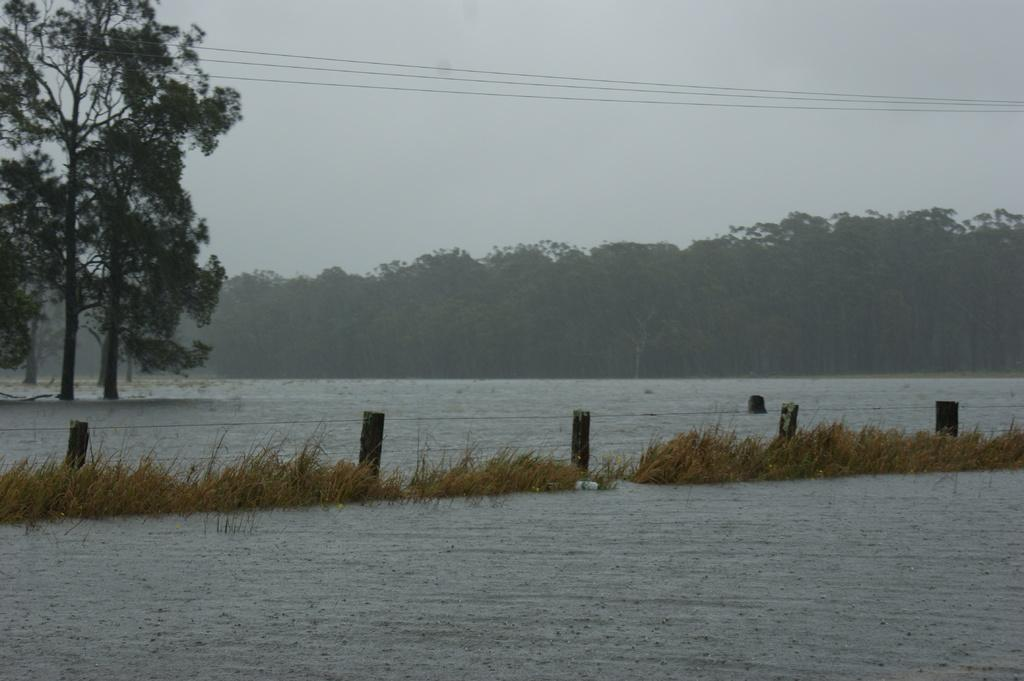What is present in the front of the image? There is water in the front of the image. What can be seen in the center of the image? There is grass in the center of the image. What is a feature that separates the grass and water in the image? There is a fence in the image. What is visible in the background of the image? There are trees and a cloudy sky in the background of the image. What is present at the top of the image? There are wires at the top of the image. Where is the cobweb located in the image? There is no cobweb present in the image. What type of string is attached to the trees in the background? There is no string attached to the trees in the background; only wires are present at the top of the image. 